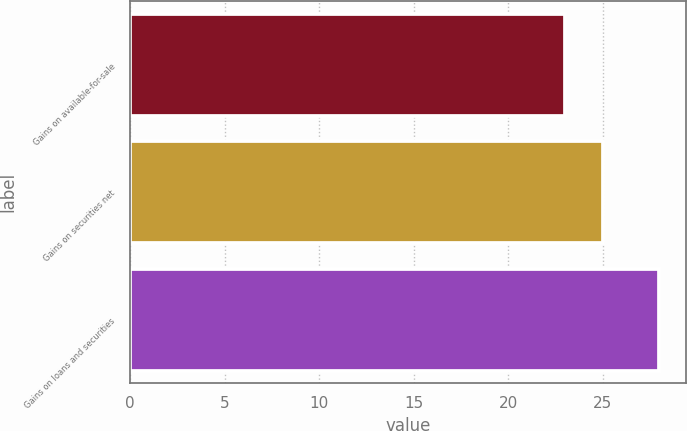Convert chart to OTSL. <chart><loc_0><loc_0><loc_500><loc_500><bar_chart><fcel>Gains on available-for-sale<fcel>Gains on securities net<fcel>Gains on loans and securities<nl><fcel>23<fcel>25<fcel>28<nl></chart> 